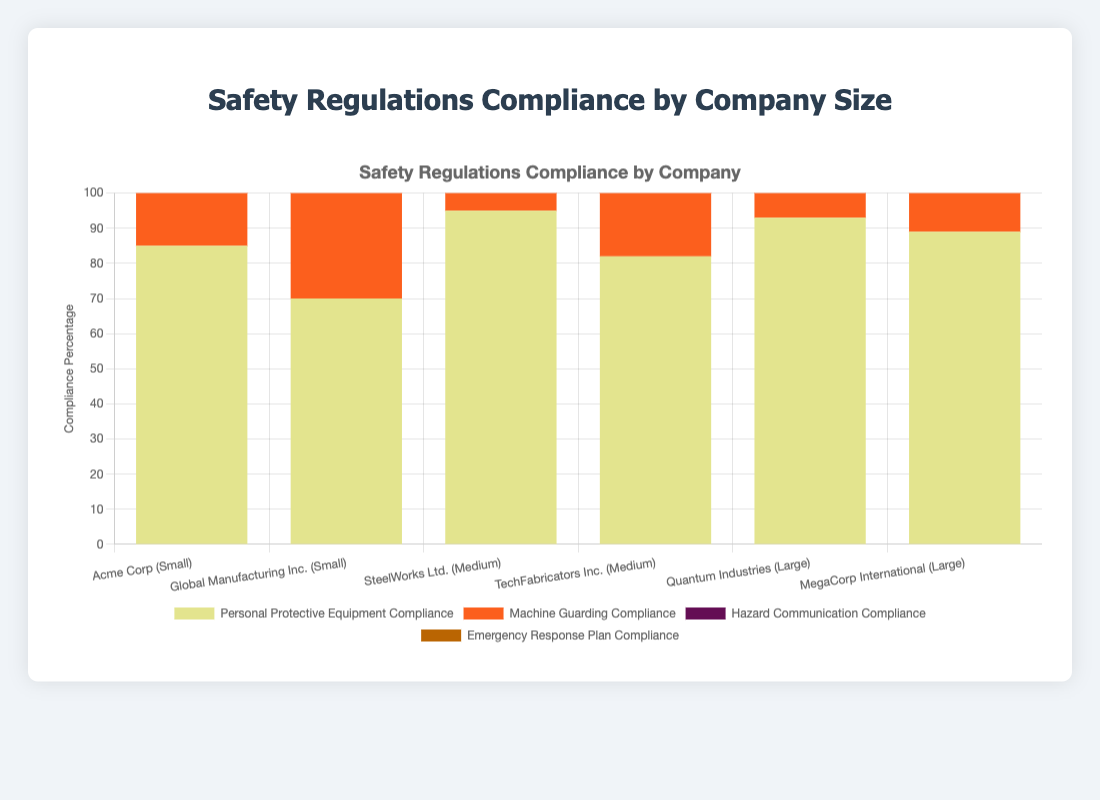Which company has the highest overall compliance percentage? Summing up the compliance percentages for each company and comparing, the company with the highest sum has the highest overall compliance. Quantum Industries: 93 + 95 + 98 + 90 = 376, among all companies, this is the highest.
Answer: Quantum Industries Between medium-sized companies, which one has a higher compliance in Personal Protective Equipment? Comparing the Personal Protective Equipment Compliance for SteelWorks Ltd. and TechFabricators Inc., SteelWorks Ltd. has 95 and TechFabricators Inc. has 82.
Answer: SteelWorks Ltd What is the average Machine Guarding Compliance among small-sized companies? Taking the Machine Guarding Compliance values for small-sized companies: 90 for Acme Corp and 85 for Global Manufacturing Inc., the average is (90 + 85) / 2 = 87.5
Answer: 87.5 Which safety regulation category had the lowest compliance for Acme Corp? Acme Corp's compliance percentages are: Personal Protective Equipment (85), Machine Guarding (90), Hazard Communication (80), and Emergency Response Plan (75). The lowest is Emergency Response Plan Compliance with 75.
Answer: Emergency Response Plan Compliance How does MegaCorp International's compliance in Hazard Communication compare to Quantum Industries? MegaCorp International has 94% compliance and Quantum Industries has 98% compliance. Quantum Industries' compliance is higher.
Answer: Quantum Industries Which company has the lowest Personal Protective Equipment Compliance among large-sized companies? Comparing the Personal Protective Equipment Compliance: Quantum Industries has 93, and MegaCorp International has 89. MegaCorp International has the lowest.
Answer: MegaCorp International What is the total compliance percentage for TechFabricators Inc. in all categories? Summing up the compliance percentages: Personal Protective Equipment (82), Machine Guarding (87), Hazard Communication (79), and Emergency Response Plan (86). Total compliance is 82 + 87 + 79 + 86 = 334.
Answer: 334 What is the average compliance in Hazard Communication across all companies? Summing the Hazard Communication compliance percentages: 80 + 88 + 85 + 79 + 98 + 94 = 524, and dividing by the number of companies (6), the average is 524 / 6 ≈ 87.33
Answer: 87.33 Which company has the smallest compliance percentage for Emergency Response Plan among the medium-sized companies? Comparing Emergency Response Plan Compliance: SteelWorks Ltd. has 88% and TechFabricators Inc. has 86%. TechFabricators Inc. has the smallest compliance.
Answer: TechFabricators Inc Among the large-sized companies, which safety regulation has the highest compliance? Comparing Personal Protective Equipment, Machine Guarding, Hazard Communication, and Emergency Response Plan Compliance for both Quantum Industries and MegaCorp International, Hazard Communication for both companies are 98% and 94% respectively. The highest is 98% for Quantum Industries.
Answer: Hazard Communication 